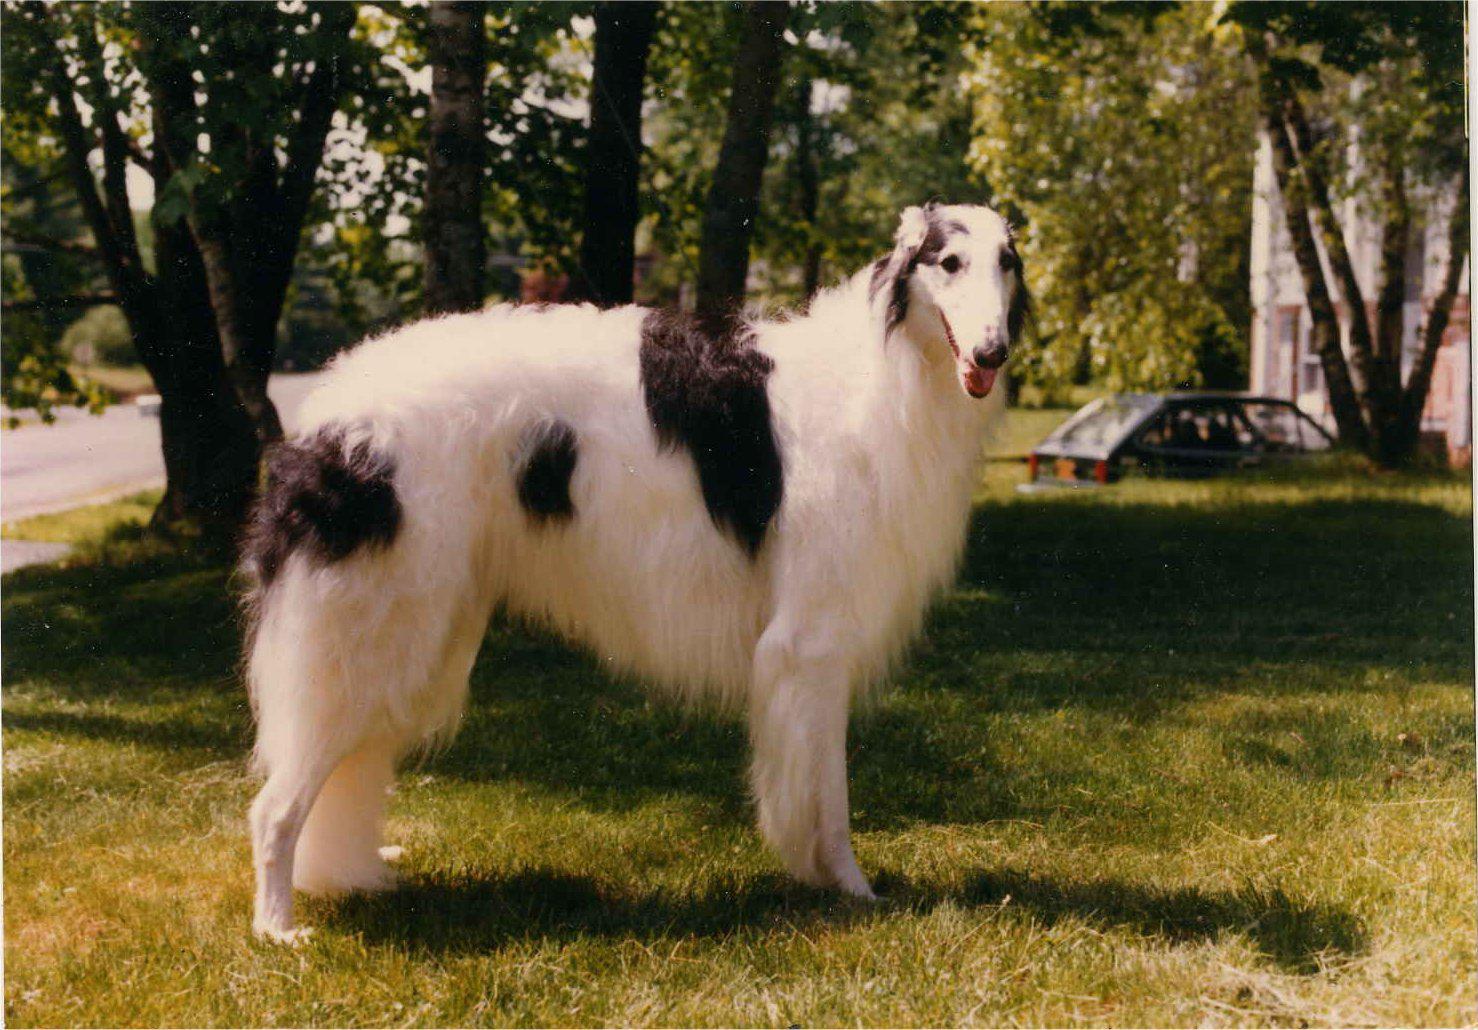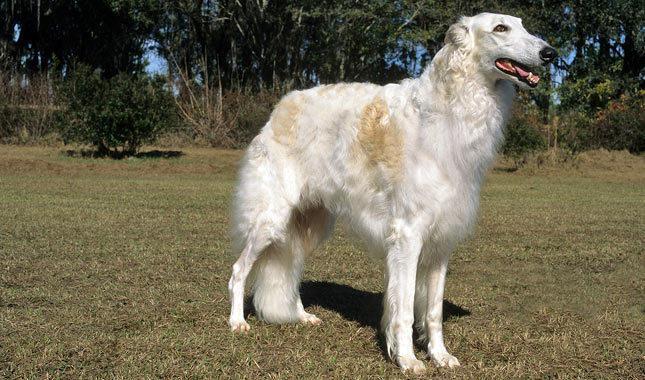The first image is the image on the left, the second image is the image on the right. For the images displayed, is the sentence "In both images the dog is turned toward the right side of the image." factually correct? Answer yes or no. Yes. 